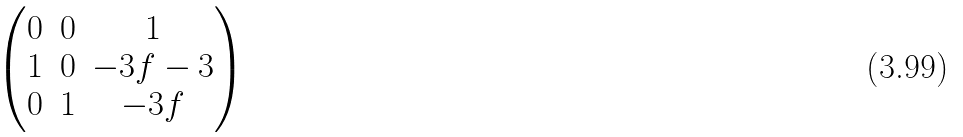<formula> <loc_0><loc_0><loc_500><loc_500>\begin{pmatrix} 0 & 0 & 1 \\ 1 & 0 & - 3 f - 3 \\ 0 & 1 & - 3 f \end{pmatrix}</formula> 